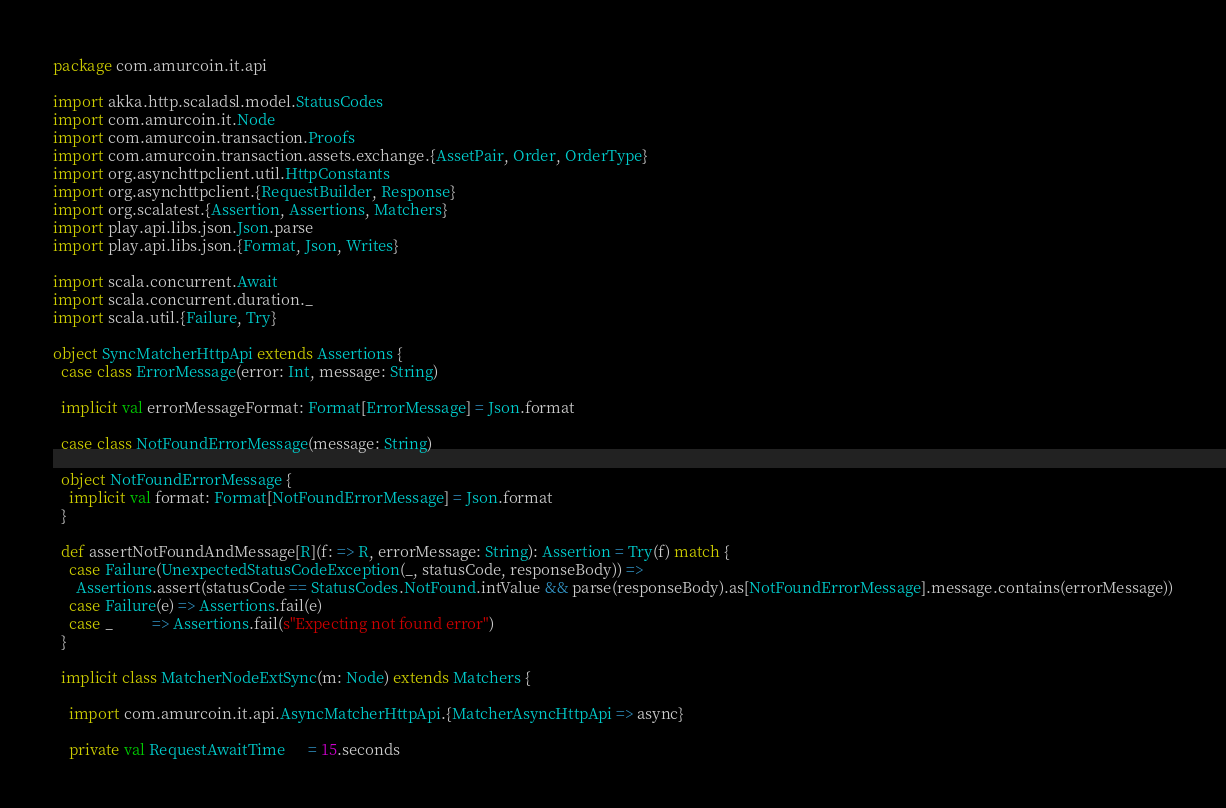<code> <loc_0><loc_0><loc_500><loc_500><_Scala_>package com.amurcoin.it.api

import akka.http.scaladsl.model.StatusCodes
import com.amurcoin.it.Node
import com.amurcoin.transaction.Proofs
import com.amurcoin.transaction.assets.exchange.{AssetPair, Order, OrderType}
import org.asynchttpclient.util.HttpConstants
import org.asynchttpclient.{RequestBuilder, Response}
import org.scalatest.{Assertion, Assertions, Matchers}
import play.api.libs.json.Json.parse
import play.api.libs.json.{Format, Json, Writes}

import scala.concurrent.Await
import scala.concurrent.duration._
import scala.util.{Failure, Try}

object SyncMatcherHttpApi extends Assertions {
  case class ErrorMessage(error: Int, message: String)

  implicit val errorMessageFormat: Format[ErrorMessage] = Json.format

  case class NotFoundErrorMessage(message: String)

  object NotFoundErrorMessage {
    implicit val format: Format[NotFoundErrorMessage] = Json.format
  }

  def assertNotFoundAndMessage[R](f: => R, errorMessage: String): Assertion = Try(f) match {
    case Failure(UnexpectedStatusCodeException(_, statusCode, responseBody)) =>
      Assertions.assert(statusCode == StatusCodes.NotFound.intValue && parse(responseBody).as[NotFoundErrorMessage].message.contains(errorMessage))
    case Failure(e) => Assertions.fail(e)
    case _          => Assertions.fail(s"Expecting not found error")
  }

  implicit class MatcherNodeExtSync(m: Node) extends Matchers {

    import com.amurcoin.it.api.AsyncMatcherHttpApi.{MatcherAsyncHttpApi => async}

    private val RequestAwaitTime      = 15.seconds</code> 